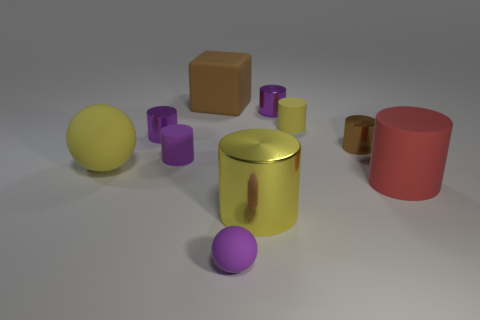Subtract all brown metallic cylinders. How many cylinders are left? 6 Add 1 large brown rubber things. How many large brown rubber things exist? 2 Subtract all yellow cylinders. How many cylinders are left? 5 Subtract 0 green balls. How many objects are left? 10 Subtract all cubes. How many objects are left? 9 Subtract 1 spheres. How many spheres are left? 1 Subtract all gray cubes. Subtract all yellow cylinders. How many cubes are left? 1 Subtract all blue spheres. How many red cylinders are left? 1 Subtract all big gray metallic things. Subtract all small purple cylinders. How many objects are left? 7 Add 2 brown rubber objects. How many brown rubber objects are left? 3 